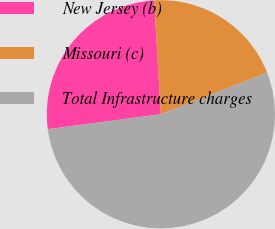<chart> <loc_0><loc_0><loc_500><loc_500><pie_chart><fcel>New Jersey (b)<fcel>Missouri (c)<fcel>Total Infrastructure charges<nl><fcel>26.15%<fcel>20.0%<fcel>53.85%<nl></chart> 